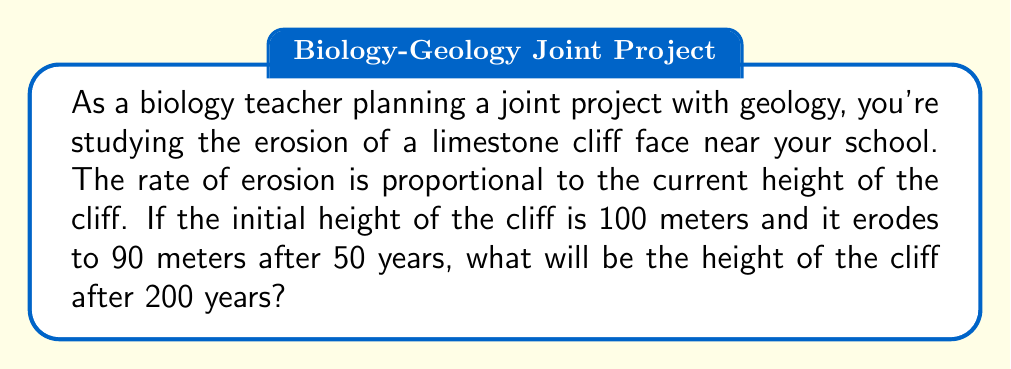Help me with this question. Let's approach this step-by-step using a differential equation:

1) Let $h(t)$ be the height of the cliff at time $t$ in years.

2) The rate of change of height is proportional to the current height:

   $$\frac{dh}{dt} = -kh$$

   where $k$ is a positive constant and the negative sign indicates decrease.

3) This differential equation has the solution:

   $$h(t) = h_0e^{-kt}$$

   where $h_0$ is the initial height.

4) We know:
   - $h_0 = 100$ meters
   - $h(50) = 90$ meters

5) Let's find $k$ using the second condition:

   $$90 = 100e^{-50k}$$

6) Solving for $k$:

   $$e^{-50k} = 0.9$$
   $$-50k = \ln(0.9)$$
   $$k = -\frac{\ln(0.9)}{50} \approx 0.002107$$

7) Now we can find the height at $t=200$ years:

   $$h(200) = 100e^{-0.002107 \times 200} \approx 65.69$$

Therefore, after 200 years, the cliff will be approximately 65.69 meters tall.
Answer: 65.69 meters 